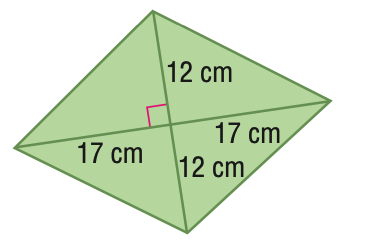Question: Find the area of the figure. Round to the nearest tenth if necessary.
Choices:
A. 204
B. 289
C. 408
D. 916
Answer with the letter. Answer: C 